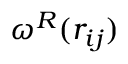Convert formula to latex. <formula><loc_0><loc_0><loc_500><loc_500>\omega ^ { R } ( r _ { i j } )</formula> 